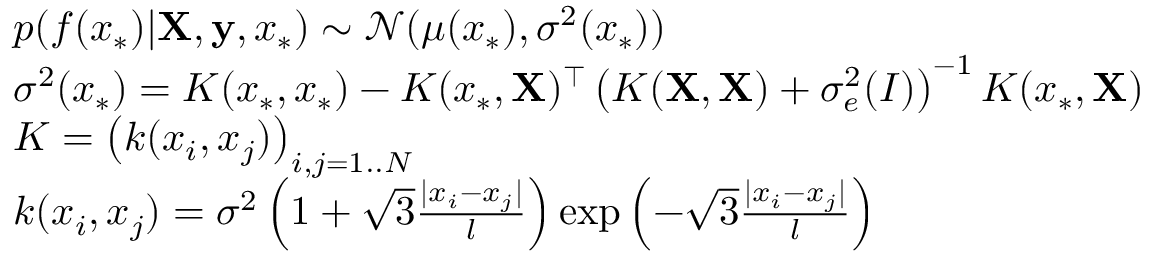Convert formula to latex. <formula><loc_0><loc_0><loc_500><loc_500>\begin{array} { r l } & { p ( f ( x _ { \ast } ) | X , y , x _ { \ast } ) \sim \mathcal { N } ( \mu ( x _ { \ast } ) , \sigma ^ { 2 } ( x _ { \ast } ) ) } \\ & { \sigma ^ { 2 } ( x _ { \ast } ) = K ( x _ { \ast } , x _ { \ast } ) - K ( x _ { \ast } , X ) ^ { \top } \left ( K ( X , X ) + \sigma _ { e } ^ { 2 } \mathbf ( I ) \right ) ^ { - 1 } K ( x _ { \ast } , X ) } \\ & { K = \left ( k ( x _ { i } , x _ { j } ) \right ) _ { i , j = 1 . . N } } \\ & { k ( x _ { i } , x _ { j } ) = \sigma ^ { 2 } \left ( 1 + \sqrt { 3 } \frac { | x _ { i } - x _ { j } | } { l } \right ) \exp \left ( - \sqrt { 3 } \frac { | x _ { i } - x _ { j } | } { l } \right ) } \end{array}</formula> 